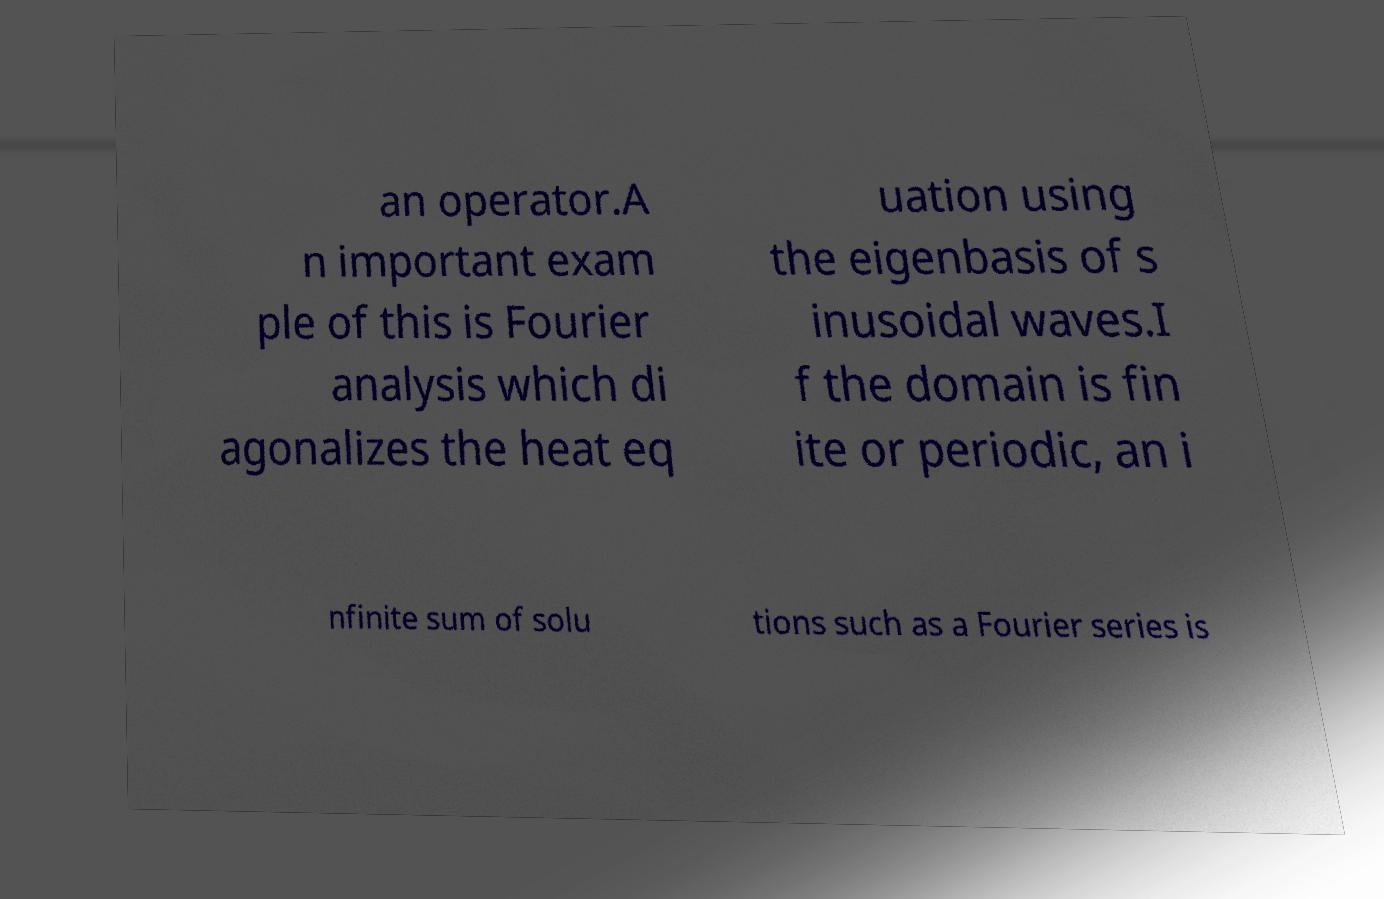Can you accurately transcribe the text from the provided image for me? an operator.A n important exam ple of this is Fourier analysis which di agonalizes the heat eq uation using the eigenbasis of s inusoidal waves.I f the domain is fin ite or periodic, an i nfinite sum of solu tions such as a Fourier series is 